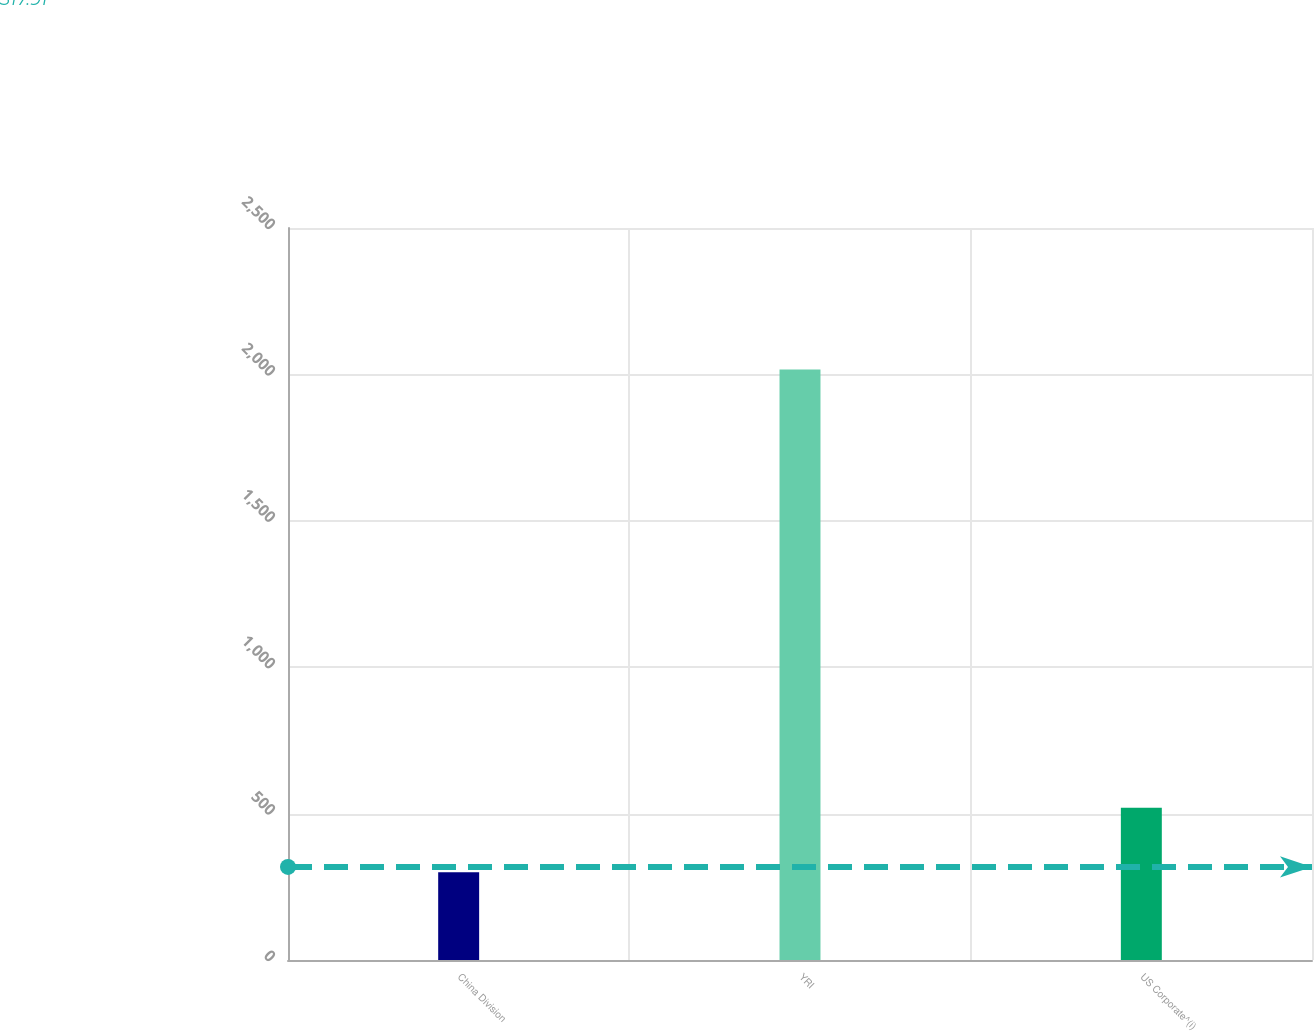Convert chart. <chart><loc_0><loc_0><loc_500><loc_500><bar_chart><fcel>China Division<fcel>YRI<fcel>US Corporate^(i)<nl><fcel>300<fcel>2017<fcel>520<nl></chart> 